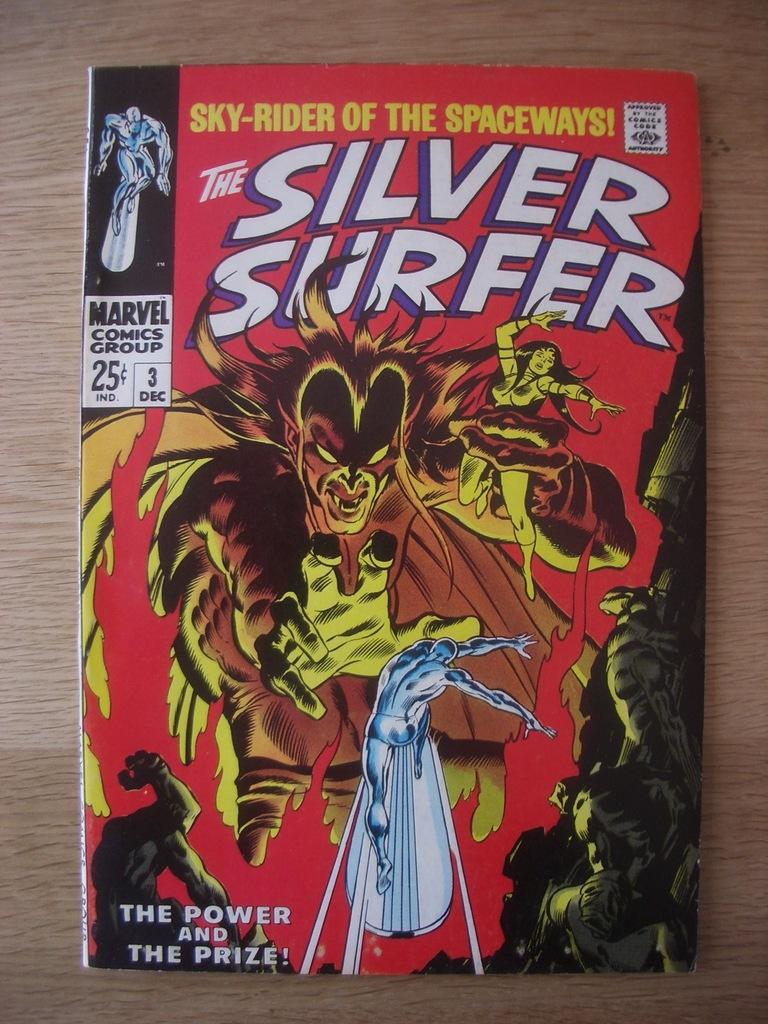<image>
Render a clear and concise summary of the photo. the name silver surfer is on the red magazine 